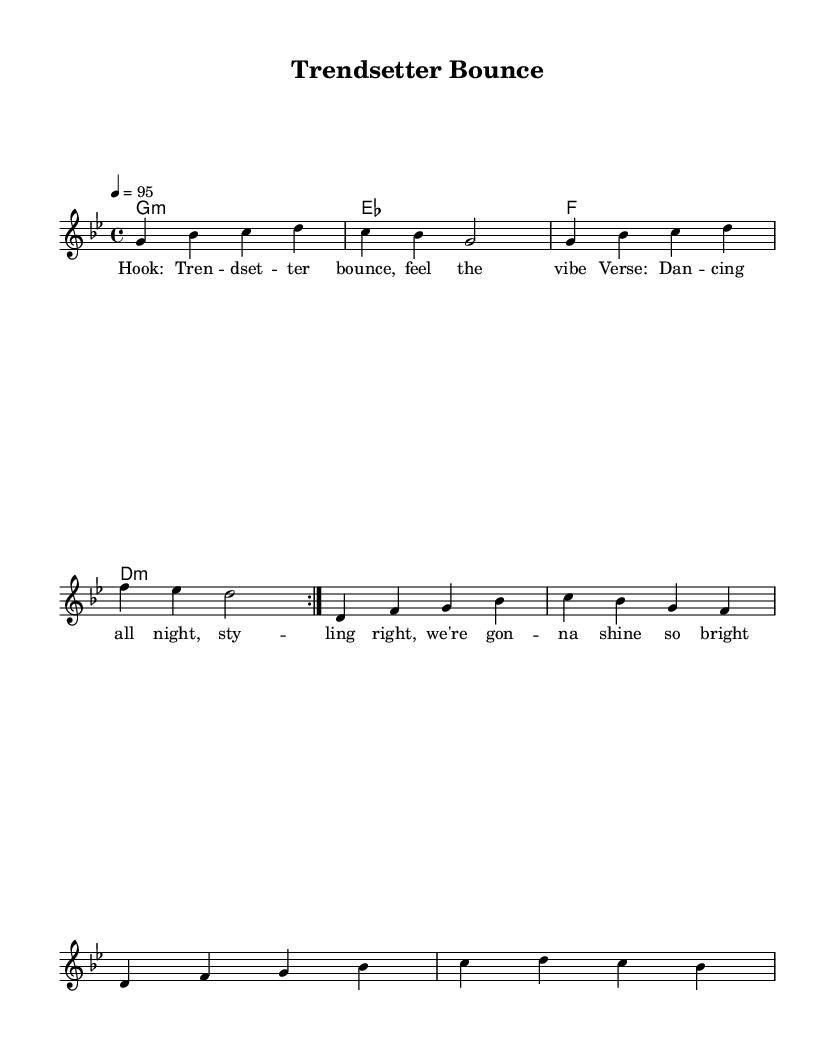What is the key signature of this music? The key signature is G minor, which has two flats (B flat and E flat).
Answer: G minor What is the time signature of this music? The time signature is found at the beginning of the score, which indicates the number of beats per measure. It is 4/4, meaning there are four quarter note beats in each measure.
Answer: 4/4 What is the tempo marking for this music? The tempo marking indicates the speed of the piece, which is set at quarter note equals 95 beats per minute.
Answer: 95 How many measures are in the melody section? Counting the measures in the melody section, it repeats twice (as indicated by "repeat volta 2") and consists of 8 measures, giving a total of 16 measures overall since each repeat has 8 measures.
Answer: 16 What lyrical theme is presented in the hook? The hook contains phrases that communicate positivity and energy, specifically emphasizing a "bounce" and a "vibe," which are essential characteristics of dancehall-influenced reggae.
Answer: Feel the vibe How does the chord progression change throughout the piece? The chord progression follows a sequence of G minor, E flat, F major, and D minor. This creates a harmonic framework that supports the melody and contributes to the rhythmic feel typical of reggae music.
Answer: G minor, E flat, F, D minor What unique feature is highlighted in the lyrics? The lyrics highlight a strong emphasis on style and confidence, with words like "styling right" and "shine so bright," which captures the essence of the dancehall culture in reggae music.
Answer: Styling right 